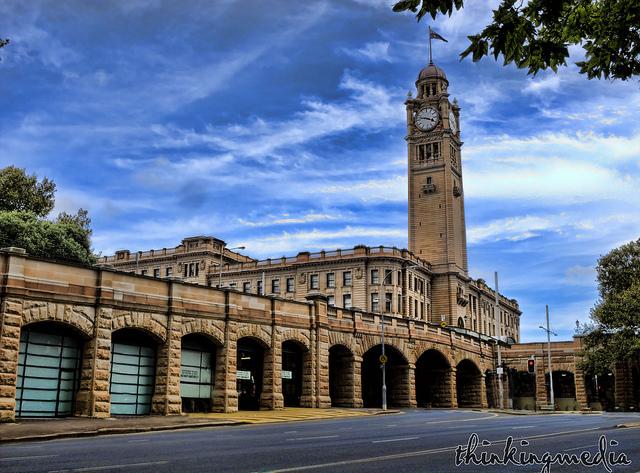What time is it?
Quick response, please. 3:50. Are there any cars?
Give a very brief answer. No. How many windows are visible?
Be succinct. 17. 